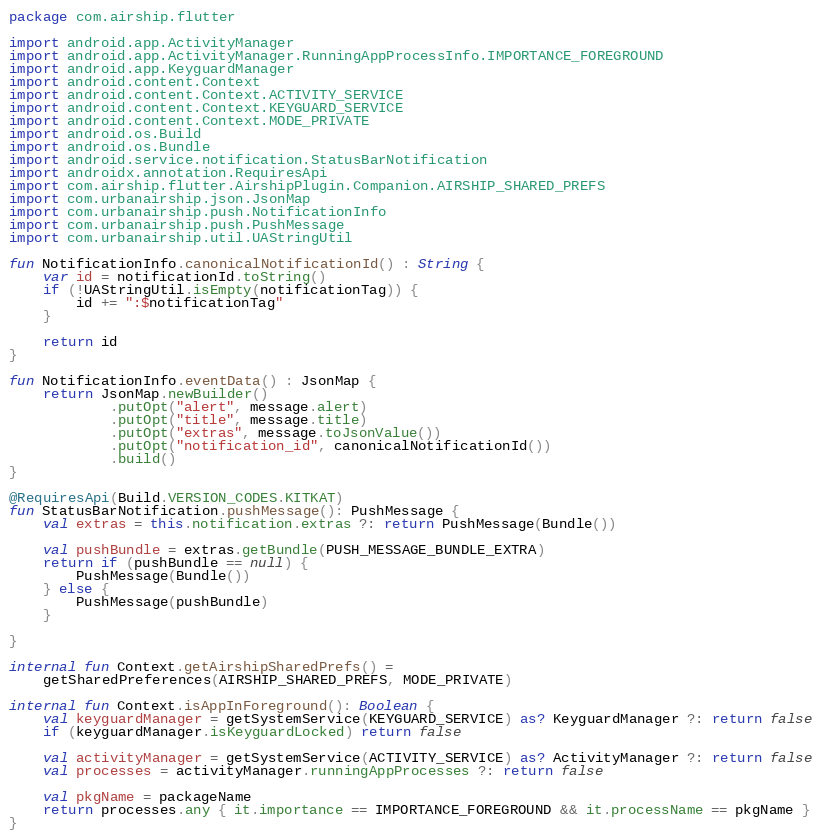<code> <loc_0><loc_0><loc_500><loc_500><_Kotlin_>package com.airship.flutter

import android.app.ActivityManager
import android.app.ActivityManager.RunningAppProcessInfo.IMPORTANCE_FOREGROUND
import android.app.KeyguardManager
import android.content.Context
import android.content.Context.ACTIVITY_SERVICE
import android.content.Context.KEYGUARD_SERVICE
import android.content.Context.MODE_PRIVATE
import android.os.Build
import android.os.Bundle
import android.service.notification.StatusBarNotification
import androidx.annotation.RequiresApi
import com.airship.flutter.AirshipPlugin.Companion.AIRSHIP_SHARED_PREFS
import com.urbanairship.json.JsonMap
import com.urbanairship.push.NotificationInfo
import com.urbanairship.push.PushMessage
import com.urbanairship.util.UAStringUtil

fun NotificationInfo.canonicalNotificationId() : String {
    var id = notificationId.toString()
    if (!UAStringUtil.isEmpty(notificationTag)) {
        id += ":$notificationTag"
    }

    return id
}

fun NotificationInfo.eventData() : JsonMap {
    return JsonMap.newBuilder()
            .putOpt("alert", message.alert)
            .putOpt("title", message.title)
            .putOpt("extras", message.toJsonValue())
            .putOpt("notification_id", canonicalNotificationId())
            .build()
}

@RequiresApi(Build.VERSION_CODES.KITKAT)
fun StatusBarNotification.pushMessage(): PushMessage {
    val extras = this.notification.extras ?: return PushMessage(Bundle())

    val pushBundle = extras.getBundle(PUSH_MESSAGE_BUNDLE_EXTRA)
    return if (pushBundle == null) {
        PushMessage(Bundle())
    } else {
        PushMessage(pushBundle)
    }

}

internal fun Context.getAirshipSharedPrefs() =
    getSharedPreferences(AIRSHIP_SHARED_PREFS, MODE_PRIVATE)

internal fun Context.isAppInForeground(): Boolean {
    val keyguardManager = getSystemService(KEYGUARD_SERVICE) as? KeyguardManager ?: return false
    if (keyguardManager.isKeyguardLocked) return false

    val activityManager = getSystemService(ACTIVITY_SERVICE) as? ActivityManager ?: return false
    val processes = activityManager.runningAppProcesses ?: return false

    val pkgName = packageName
    return processes.any { it.importance == IMPORTANCE_FOREGROUND && it.processName == pkgName }
}
</code> 